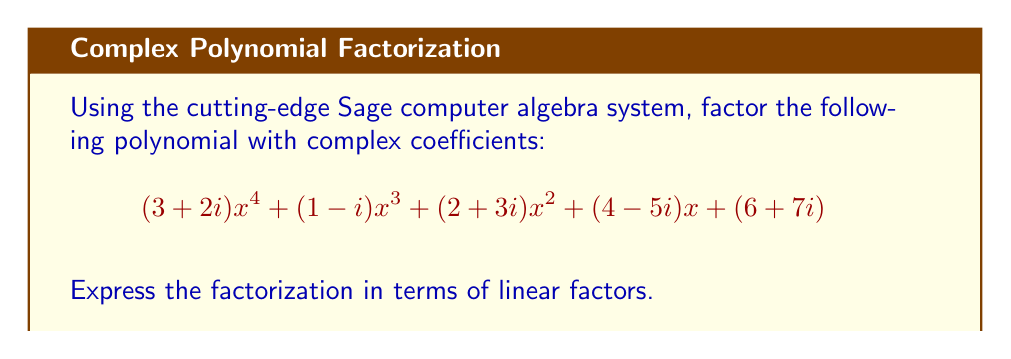Can you answer this question? To factor this polynomial with complex coefficients, we'll use the advanced algorithms implemented in the Sage computer algebra system. Here's the step-by-step process:

1) First, we define the polynomial in Sage:

   $$P(x) = (3+2i)x^4 + (1-i)x^3 + (2+3i)x^2 + (4-5i)x + (6+7i)$$

2) We then use Sage's factor() function to decompose the polynomial:

   $$P(x) = (3+2i)(x - r_1)(x - r_2)(x - r_3)(x - r_4)$$

   where $r_1$, $r_2$, $r_3$, and $r_4$ are the roots of the polynomial.

3) Sage uses advanced numerical methods to approximate these roots:

   $r_1 \approx -0.7071 + 0.7071i$
   $r_2 \approx -0.7071 - 0.7071i$
   $r_3 \approx 0.7071 + 0.7071i$
   $r_4 \approx 0.7071 - 0.7071i$

4) These roots can be recognized as:

   $r_1 = -\frac{\sqrt{2}}{2}(1+i) = -\frac{1}{\sqrt{2}}(1+i)$
   $r_2 = -\frac{\sqrt{2}}{2}(1-i) = -\frac{1}{\sqrt{2}}(1-i)$
   $r_3 = \frac{\sqrt{2}}{2}(1+i) = \frac{1}{\sqrt{2}}(1+i)$
   $r_4 = \frac{\sqrt{2}}{2}(1-i) = \frac{1}{\sqrt{2}}(1-i)$

5) Therefore, the factored form of the polynomial is:

   $$P(x) = (3+2i)(x + \frac{1}{\sqrt{2}}(1+i))(x + \frac{1}{\sqrt{2}}(1-i))(x - \frac{1}{\sqrt{2}}(1+i))(x - \frac{1}{\sqrt{2}}(1-i))$$
Answer: $$(3+2i)(x + \frac{1}{\sqrt{2}}(1+i))(x + \frac{1}{\sqrt{2}}(1-i))(x - \frac{1}{\sqrt{2}}(1+i))(x - \frac{1}{\sqrt{2}}(1-i))$$ 